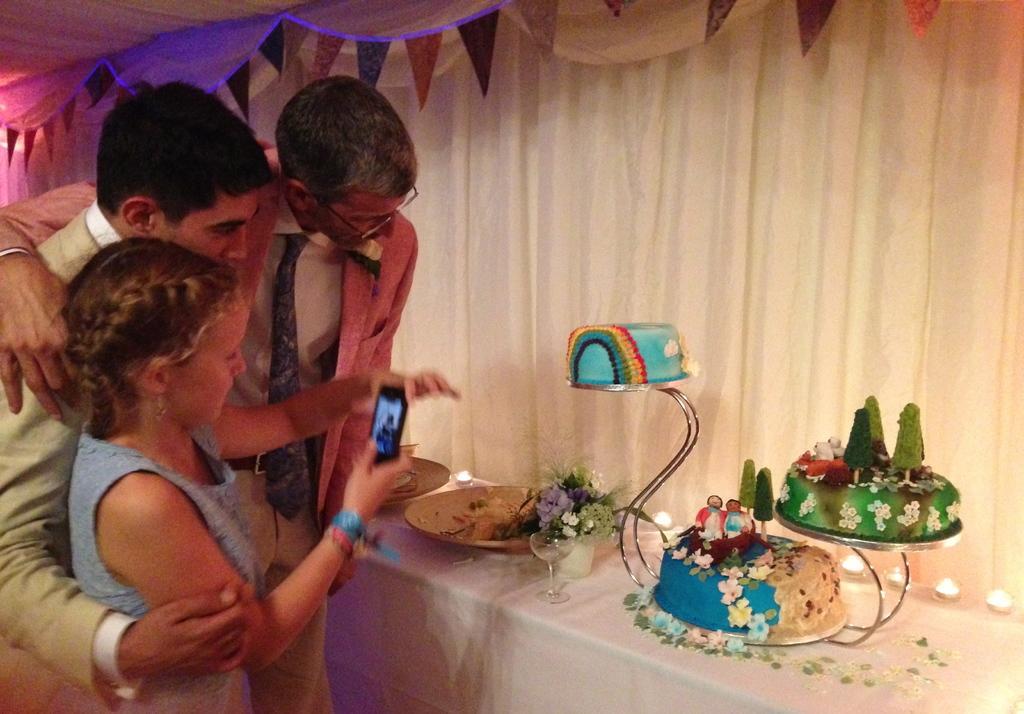Please provide a concise description of this image. In this image there are people, curtain, flags, table, cakes, plate, glass, flowers and objects. A girl is holding a mobile.   